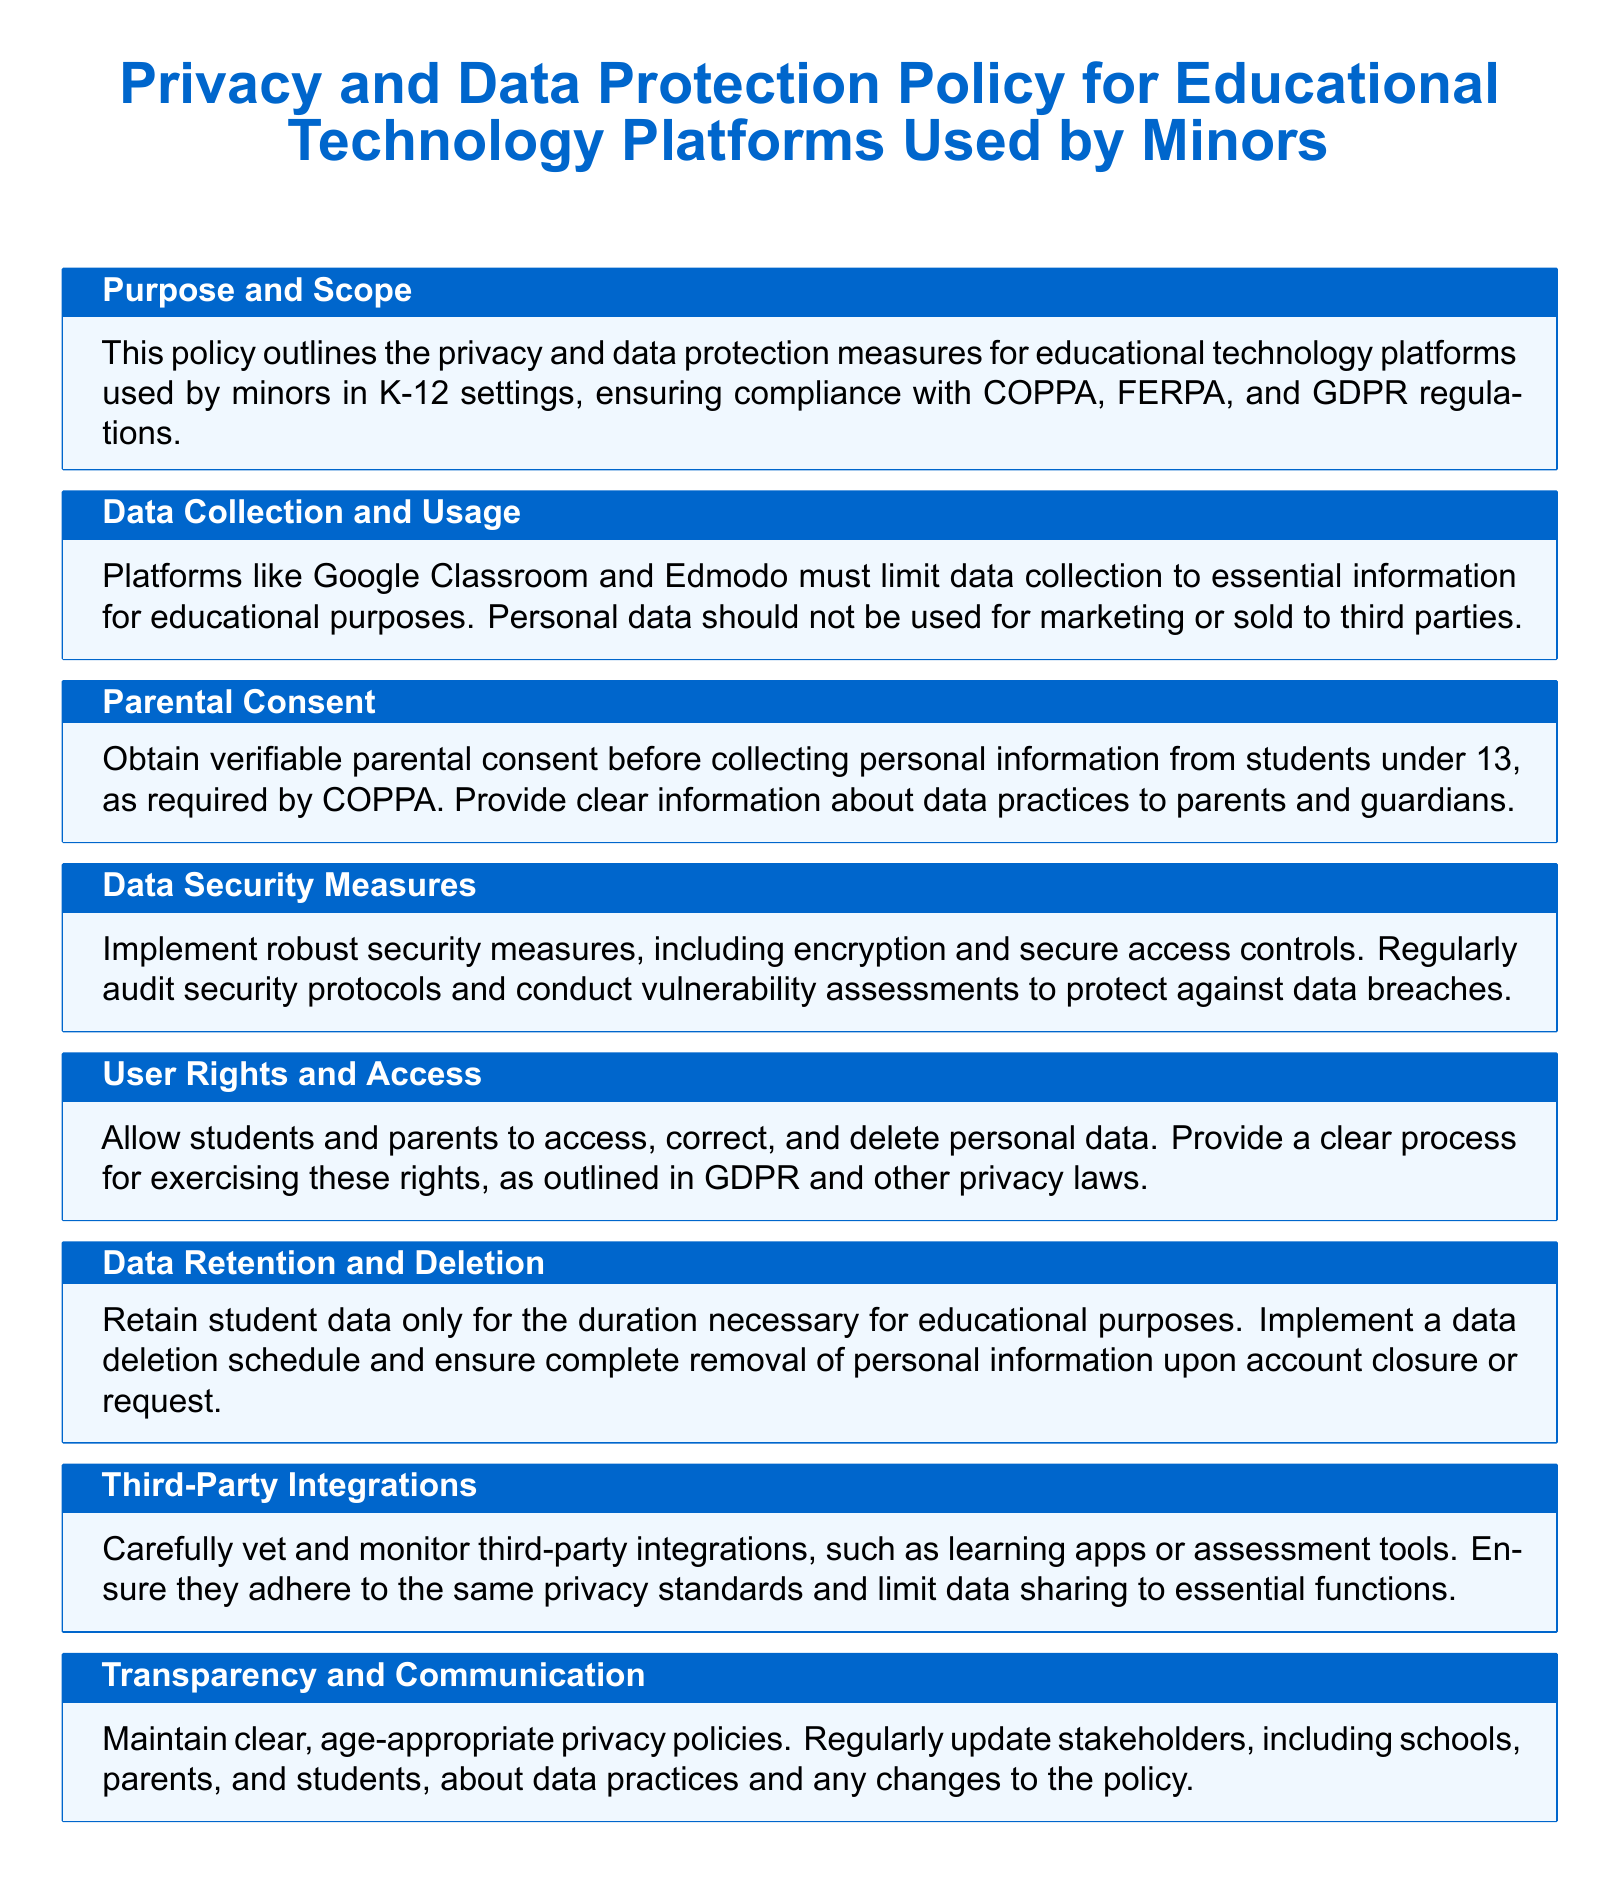What is the purpose of this policy? The purpose outlines privacy and data protection measures for educational technology platforms, ensuring compliance with regulations.
Answer: Compliance with COPPA, FERPA, and GDPR What must platforms like Google Classroom limit? This refers to the type of information they collect from users to ensure data protection.
Answer: Data collection to essential information What is required before collecting personal information from students under 13? This question addresses the legal requirement for parental consent outlined in the document.
Answer: Verifiable parental consent What data security measure is mentioned in the document? The document specifies a specific security practice to protect student data from breaches.
Answer: Encryption What rights are students and parents allowed regarding personal data? This outlines the rights provided to users concerning their personal data.
Answer: Access, correct, and delete How long should student data be retained? The policy addresses the duration for which student data should be held.
Answer: Only for the duration necessary What should be carefully vetted according to the policy? This refers to external services or tools that may interact with the educational platform.
Answer: Third-party integrations What type of policies should be maintained for transparency? This concerns the accessibility and clarity of privacy-related information for users.
Answer: Clear, age-appropriate privacy policies 